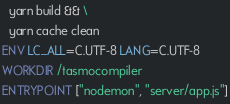Convert code to text. <code><loc_0><loc_0><loc_500><loc_500><_Dockerfile_>  yarn build && \
  yarn cache clean
ENV LC_ALL=C.UTF-8 LANG=C.UTF-8
WORKDIR /tasmocompiler
ENTRYPOINT ["nodemon", "server/app.js"]
</code> 